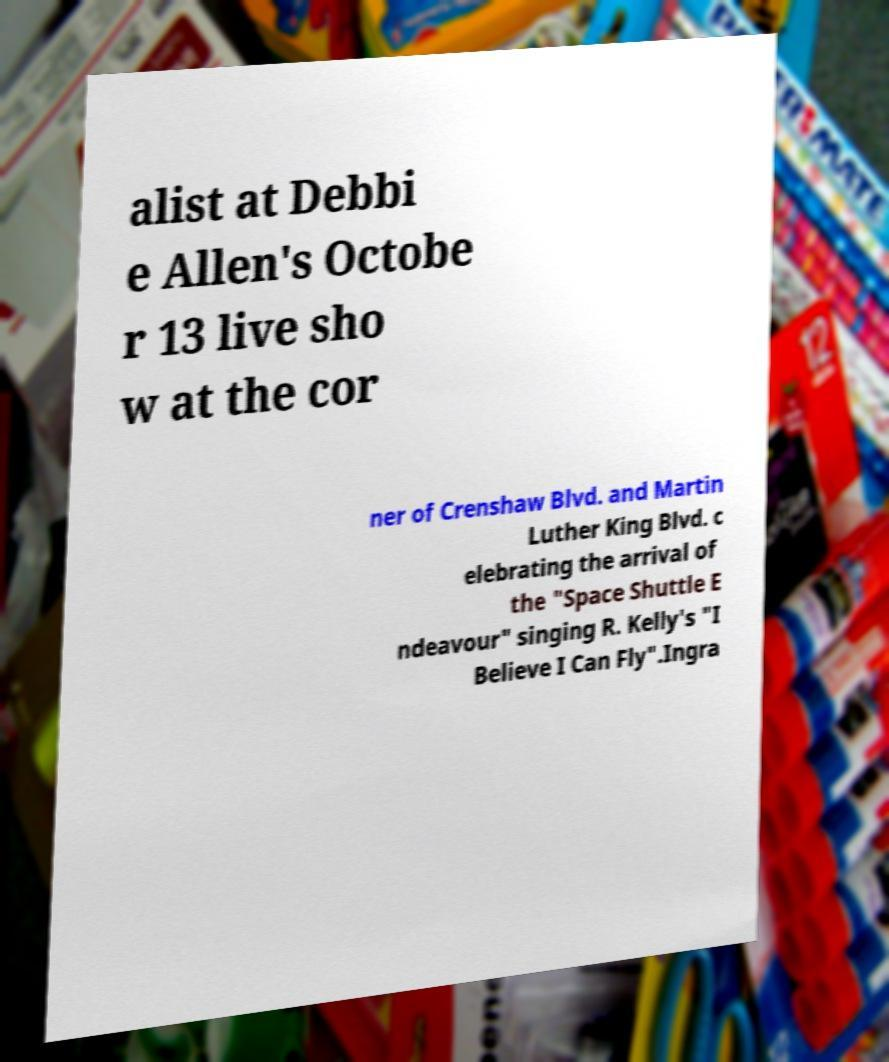Could you extract and type out the text from this image? alist at Debbi e Allen's Octobe r 13 live sho w at the cor ner of Crenshaw Blvd. and Martin Luther King Blvd. c elebrating the arrival of the "Space Shuttle E ndeavour" singing R. Kelly's "I Believe I Can Fly".Ingra 